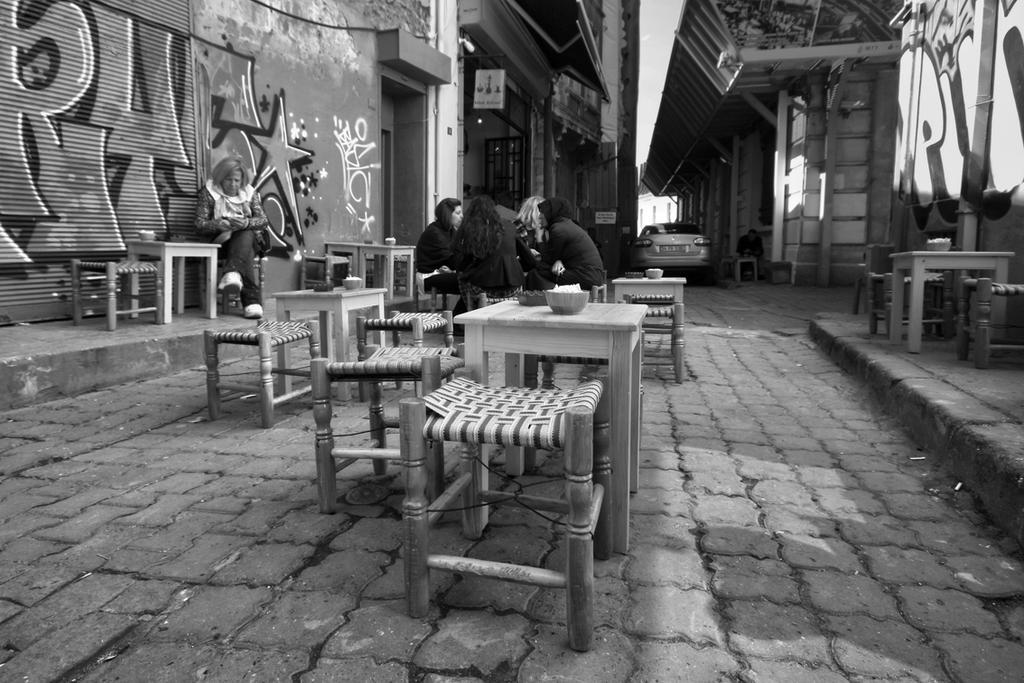In one or two sentences, can you explain what this image depicts? In this image, There are some persons sitting on the chair in front of the table. There is a wall behind this person. There is a car between these buildings. There is a bowl on this table. 